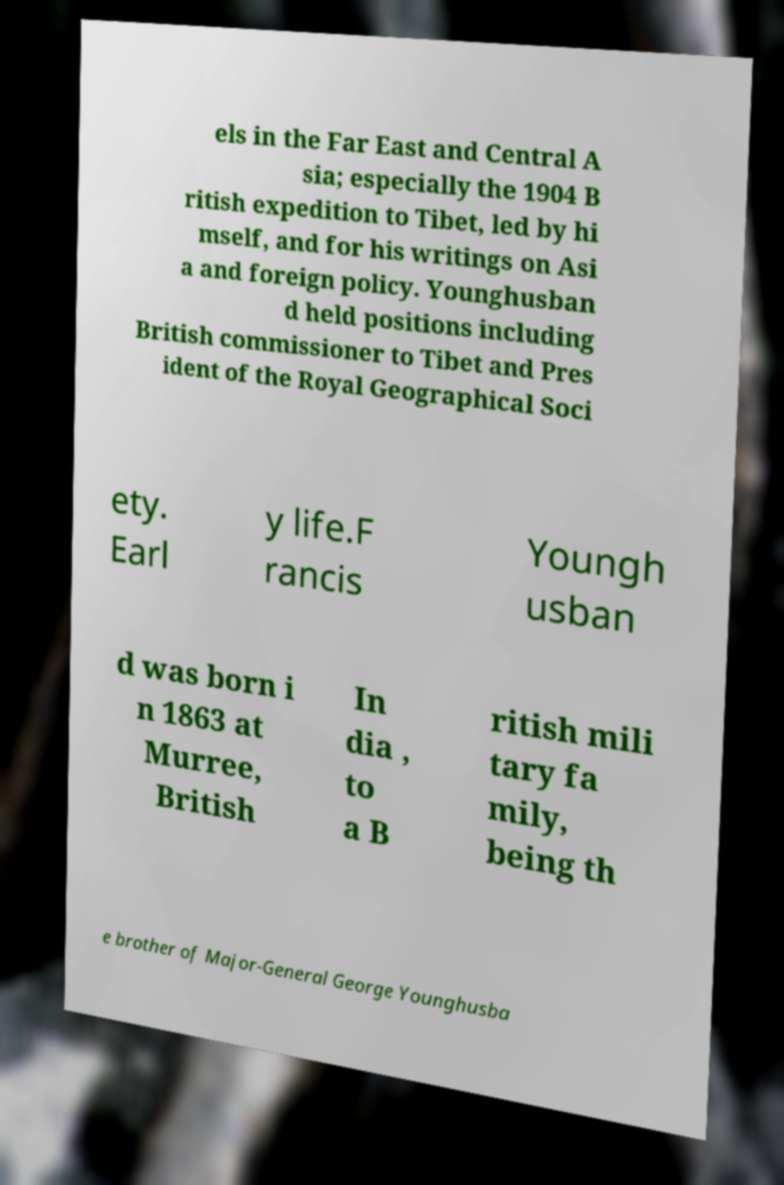Could you assist in decoding the text presented in this image and type it out clearly? els in the Far East and Central A sia; especially the 1904 B ritish expedition to Tibet, led by hi mself, and for his writings on Asi a and foreign policy. Younghusban d held positions including British commissioner to Tibet and Pres ident of the Royal Geographical Soci ety. Earl y life.F rancis Youngh usban d was born i n 1863 at Murree, British In dia , to a B ritish mili tary fa mily, being th e brother of Major-General George Younghusba 